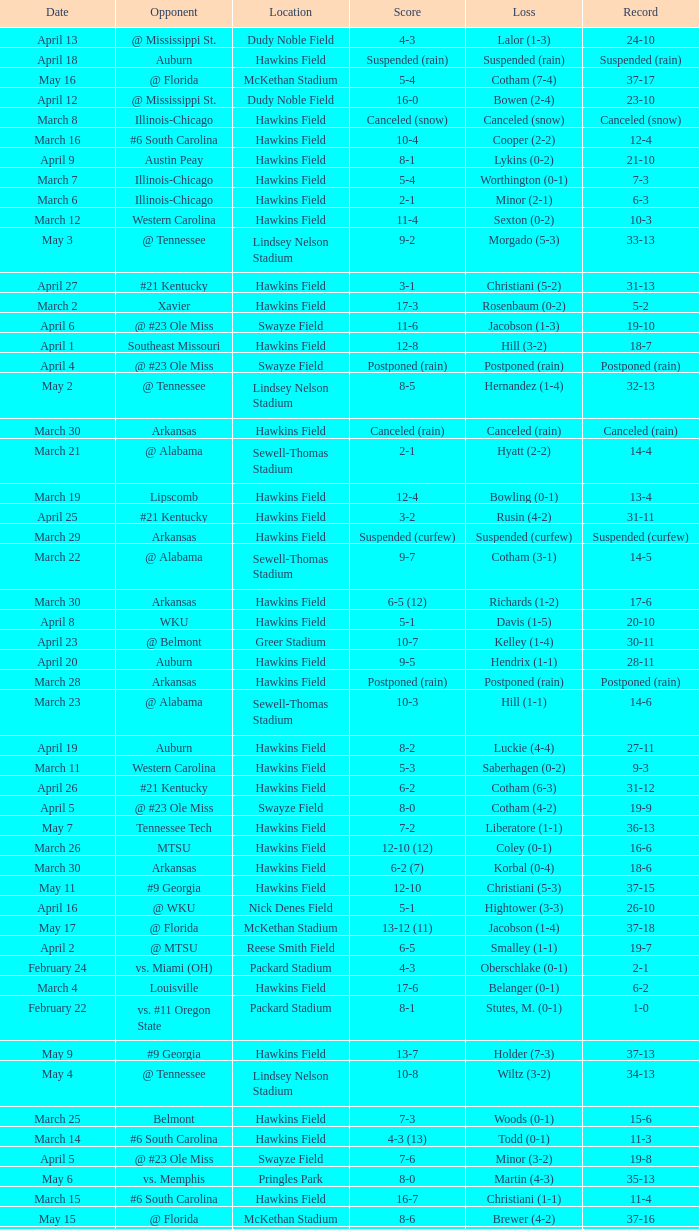What was the location of the game when the record was 12-4? Hawkins Field. 